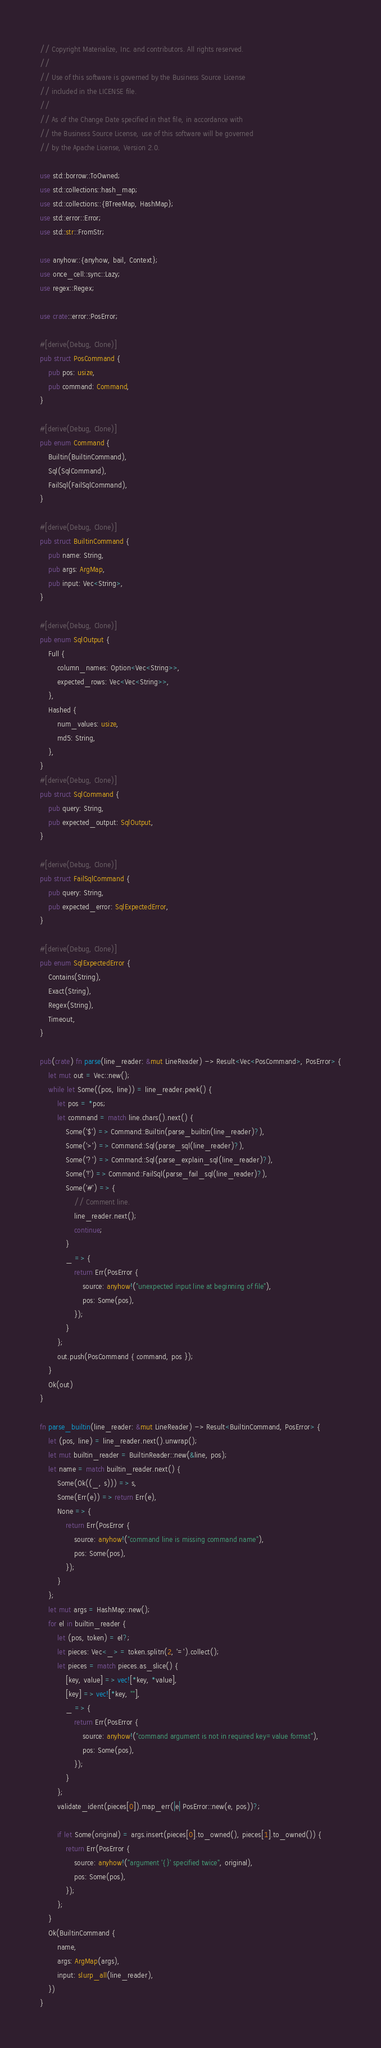Convert code to text. <code><loc_0><loc_0><loc_500><loc_500><_Rust_>// Copyright Materialize, Inc. and contributors. All rights reserved.
//
// Use of this software is governed by the Business Source License
// included in the LICENSE file.
//
// As of the Change Date specified in that file, in accordance with
// the Business Source License, use of this software will be governed
// by the Apache License, Version 2.0.

use std::borrow::ToOwned;
use std::collections::hash_map;
use std::collections::{BTreeMap, HashMap};
use std::error::Error;
use std::str::FromStr;

use anyhow::{anyhow, bail, Context};
use once_cell::sync::Lazy;
use regex::Regex;

use crate::error::PosError;

#[derive(Debug, Clone)]
pub struct PosCommand {
    pub pos: usize,
    pub command: Command,
}

#[derive(Debug, Clone)]
pub enum Command {
    Builtin(BuiltinCommand),
    Sql(SqlCommand),
    FailSql(FailSqlCommand),
}

#[derive(Debug, Clone)]
pub struct BuiltinCommand {
    pub name: String,
    pub args: ArgMap,
    pub input: Vec<String>,
}

#[derive(Debug, Clone)]
pub enum SqlOutput {
    Full {
        column_names: Option<Vec<String>>,
        expected_rows: Vec<Vec<String>>,
    },
    Hashed {
        num_values: usize,
        md5: String,
    },
}
#[derive(Debug, Clone)]
pub struct SqlCommand {
    pub query: String,
    pub expected_output: SqlOutput,
}

#[derive(Debug, Clone)]
pub struct FailSqlCommand {
    pub query: String,
    pub expected_error: SqlExpectedError,
}

#[derive(Debug, Clone)]
pub enum SqlExpectedError {
    Contains(String),
    Exact(String),
    Regex(String),
    Timeout,
}

pub(crate) fn parse(line_reader: &mut LineReader) -> Result<Vec<PosCommand>, PosError> {
    let mut out = Vec::new();
    while let Some((pos, line)) = line_reader.peek() {
        let pos = *pos;
        let command = match line.chars().next() {
            Some('$') => Command::Builtin(parse_builtin(line_reader)?),
            Some('>') => Command::Sql(parse_sql(line_reader)?),
            Some('?') => Command::Sql(parse_explain_sql(line_reader)?),
            Some('!') => Command::FailSql(parse_fail_sql(line_reader)?),
            Some('#') => {
                // Comment line.
                line_reader.next();
                continue;
            }
            _ => {
                return Err(PosError {
                    source: anyhow!("unexpected input line at beginning of file"),
                    pos: Some(pos),
                });
            }
        };
        out.push(PosCommand { command, pos });
    }
    Ok(out)
}

fn parse_builtin(line_reader: &mut LineReader) -> Result<BuiltinCommand, PosError> {
    let (pos, line) = line_reader.next().unwrap();
    let mut builtin_reader = BuiltinReader::new(&line, pos);
    let name = match builtin_reader.next() {
        Some(Ok((_, s))) => s,
        Some(Err(e)) => return Err(e),
        None => {
            return Err(PosError {
                source: anyhow!("command line is missing command name"),
                pos: Some(pos),
            });
        }
    };
    let mut args = HashMap::new();
    for el in builtin_reader {
        let (pos, token) = el?;
        let pieces: Vec<_> = token.splitn(2, '=').collect();
        let pieces = match pieces.as_slice() {
            [key, value] => vec![*key, *value],
            [key] => vec![*key, ""],
            _ => {
                return Err(PosError {
                    source: anyhow!("command argument is not in required key=value format"),
                    pos: Some(pos),
                });
            }
        };
        validate_ident(pieces[0]).map_err(|e| PosError::new(e, pos))?;

        if let Some(original) = args.insert(pieces[0].to_owned(), pieces[1].to_owned()) {
            return Err(PosError {
                source: anyhow!("argument '{}' specified twice", original),
                pos: Some(pos),
            });
        };
    }
    Ok(BuiltinCommand {
        name,
        args: ArgMap(args),
        input: slurp_all(line_reader),
    })
}
</code> 